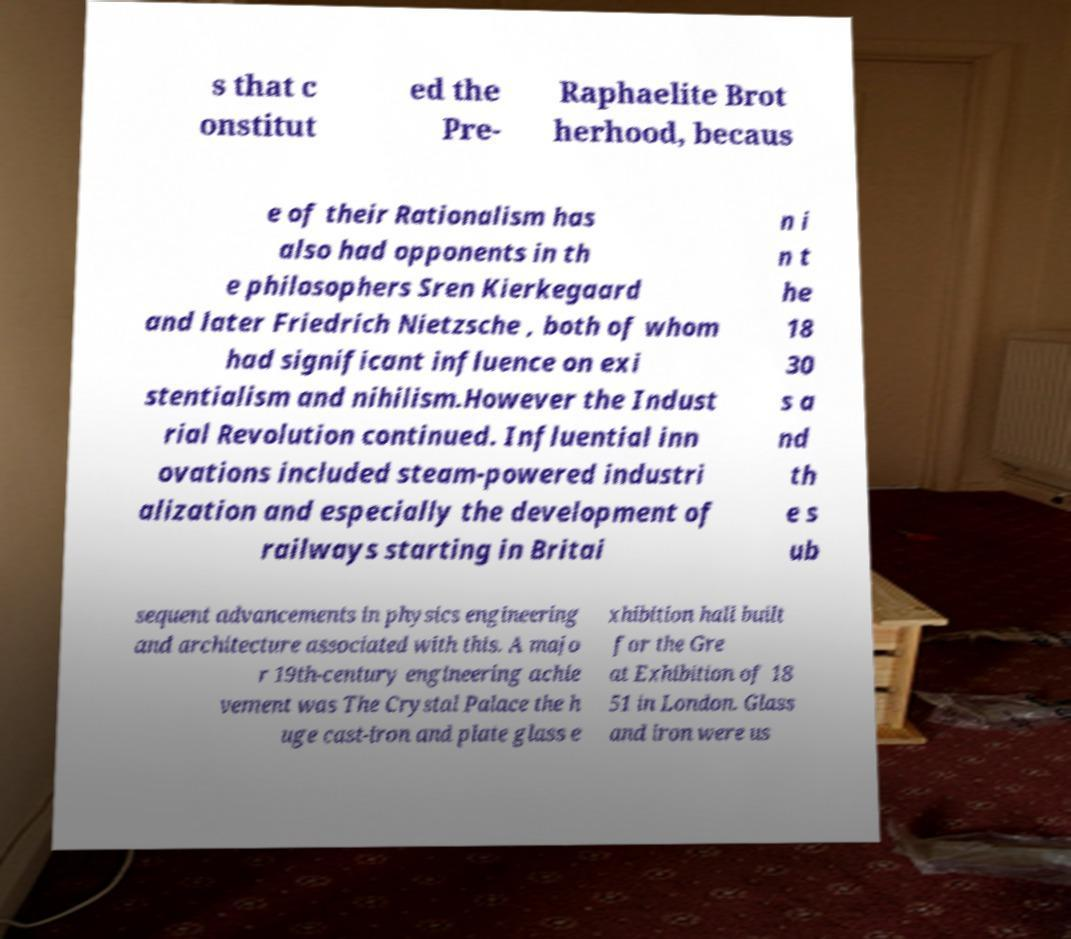Could you assist in decoding the text presented in this image and type it out clearly? s that c onstitut ed the Pre- Raphaelite Brot herhood, becaus e of their Rationalism has also had opponents in th e philosophers Sren Kierkegaard and later Friedrich Nietzsche , both of whom had significant influence on exi stentialism and nihilism.However the Indust rial Revolution continued. Influential inn ovations included steam-powered industri alization and especially the development of railways starting in Britai n i n t he 18 30 s a nd th e s ub sequent advancements in physics engineering and architecture associated with this. A majo r 19th-century engineering achie vement was The Crystal Palace the h uge cast-iron and plate glass e xhibition hall built for the Gre at Exhibition of 18 51 in London. Glass and iron were us 